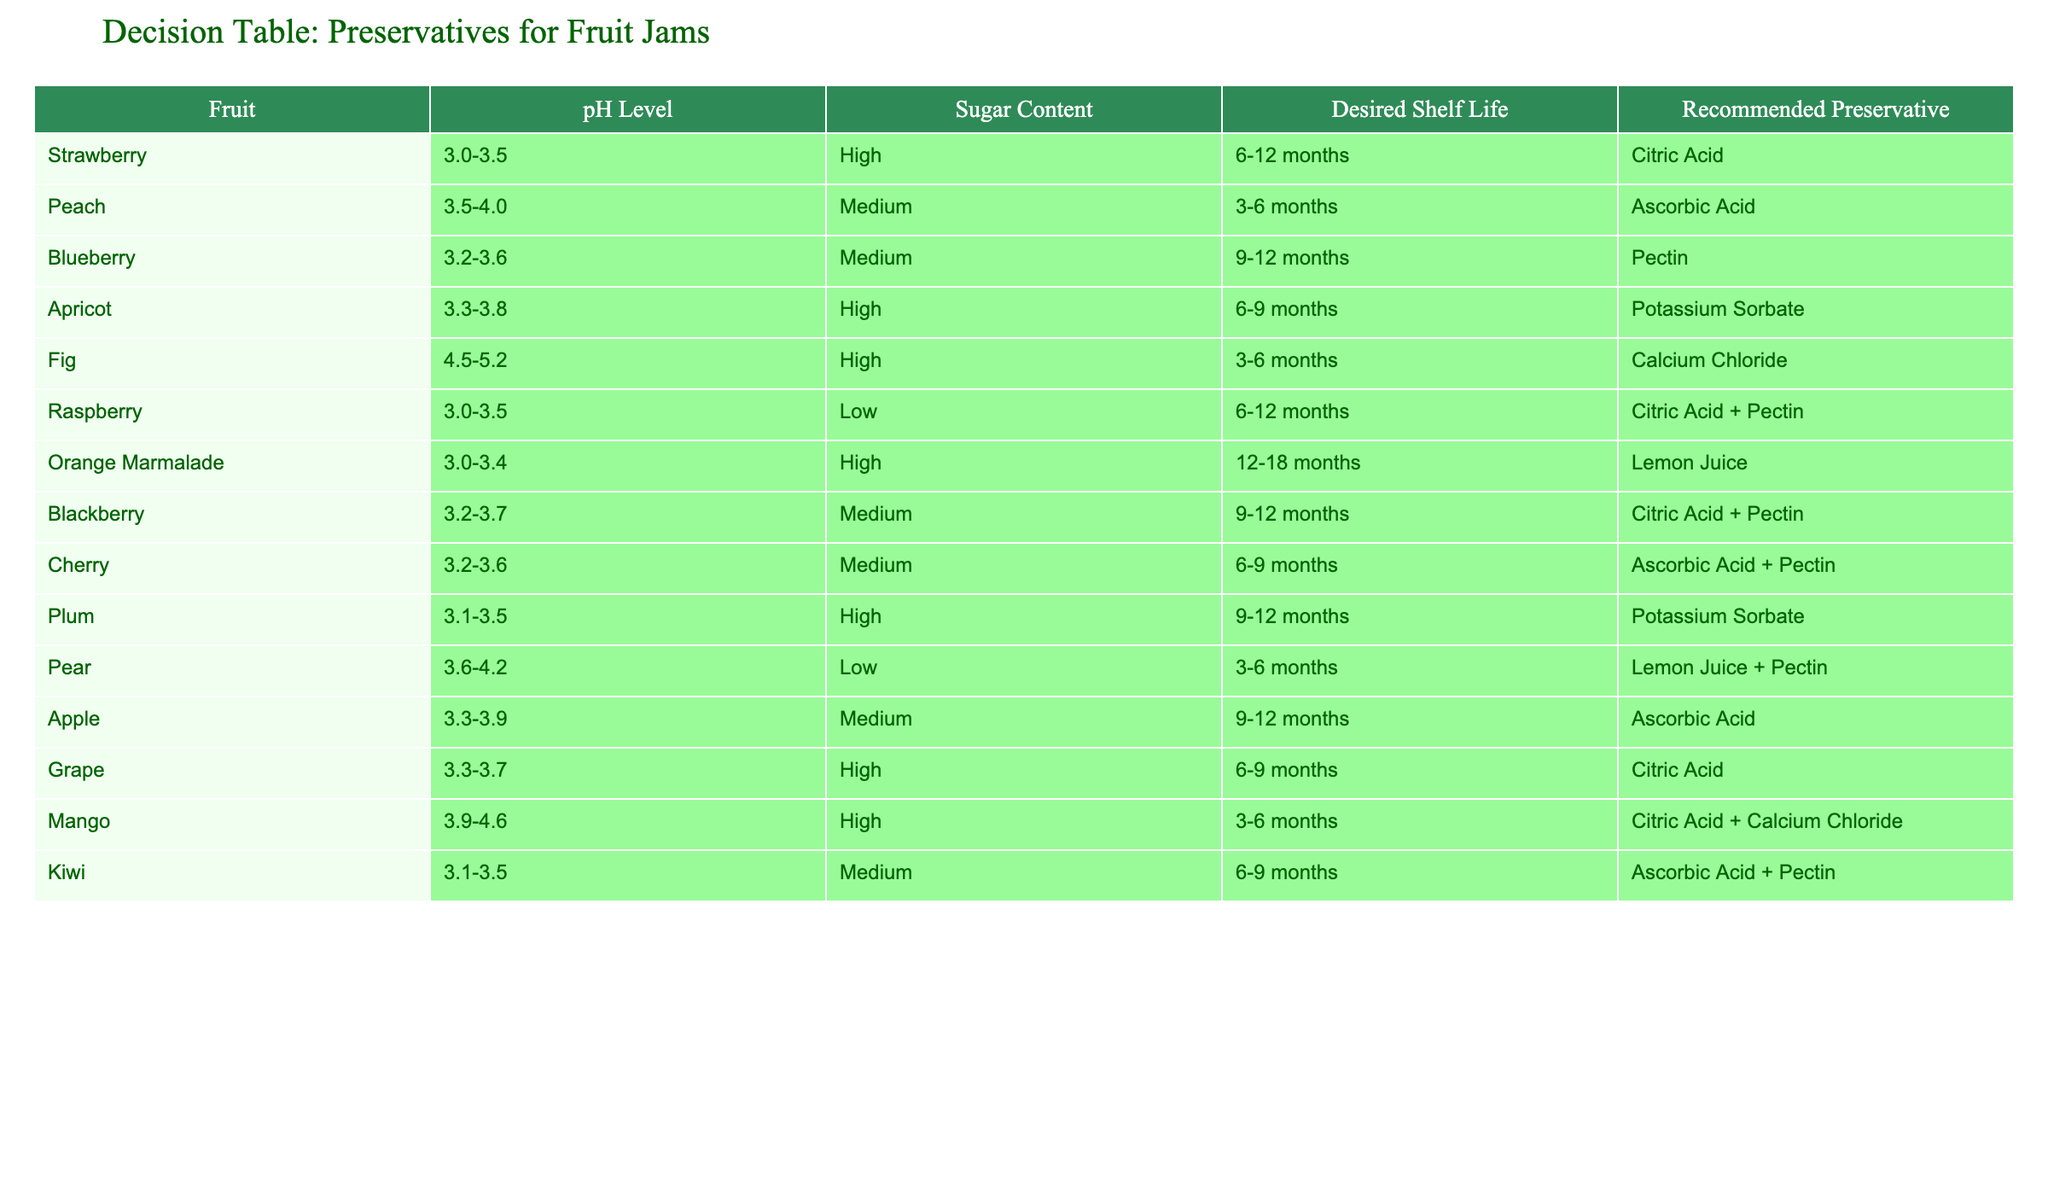What is the recommended preservative for strawberry jam? The table specifies that for strawberry jam, which has a pH level of 3.0-3.5 and high sugar content with a desired shelf life of 6-12 months, the recommended preservative is citric acid.
Answer: Citric Acid Which fruit jam requires lemon juice as a preservative? Based on the table, lemon juice is recommended for pear jam which has a pH level of 3.6-4.2, low sugar content, and a desired shelf life of 3-6 months. Additionally, it is also recommended for orange marmalade with a pH level of 3.0-3.4, high sugar content, and a desired shelf life of 12-18 months.
Answer: Pear and Orange Marmalade Is potassium sorbate recommended for high sugar content jams? Yes, according to the table, potassium sorbate is listed as a recommended preservative for apricot jam and plum jam, both of which have high sugar content.
Answer: Yes Which fruit jams have a medium sugar content and require pectin? The table shows that raspberry jam and cherry jam have medium sugar content and both recommend the use of pectin as a preservative. Raspberry jam pairs it with citric acid, and cherry jam also uses ascorbic acid.
Answer: Raspberry and Cherry What is the average pH level of fruits that use citric acid as a preservative? To find the average pH level of the fruits using citric acid, we consider strawberry (3.0-3.5), blackberry (3.2-3.7), and grape (3.3-3.7). The midpoint values are 3.25, 3.45, and 3.5 respectively. Adding these (3.25 + 3.45 + 3.5 = 10.2) and dividing by 3 gives an average pH level of 3.4.
Answer: 3.4 What is the desired shelf life for raspberry jam and how does it compare with peach jam? Raspberry jam has a desired shelf life of 6-12 months, while peach jam has a desired shelf life of 3-6 months. Thus, raspberry jam has a longer shelf life compared to peach jam.
Answer: Longer for raspberry jam How many fruit jams have a desired shelf life of 6-9 months? The table shows that four jams have a desired shelf life of 6-9 months: apricot, grape, cherry, and mango. Therefore, there are four jams in this category.
Answer: Four jams Which fruit has the highest pH level listed in the table? The highest pH level in the table belongs to fig, with a pH range of 4.5-5.2.
Answer: Fig 